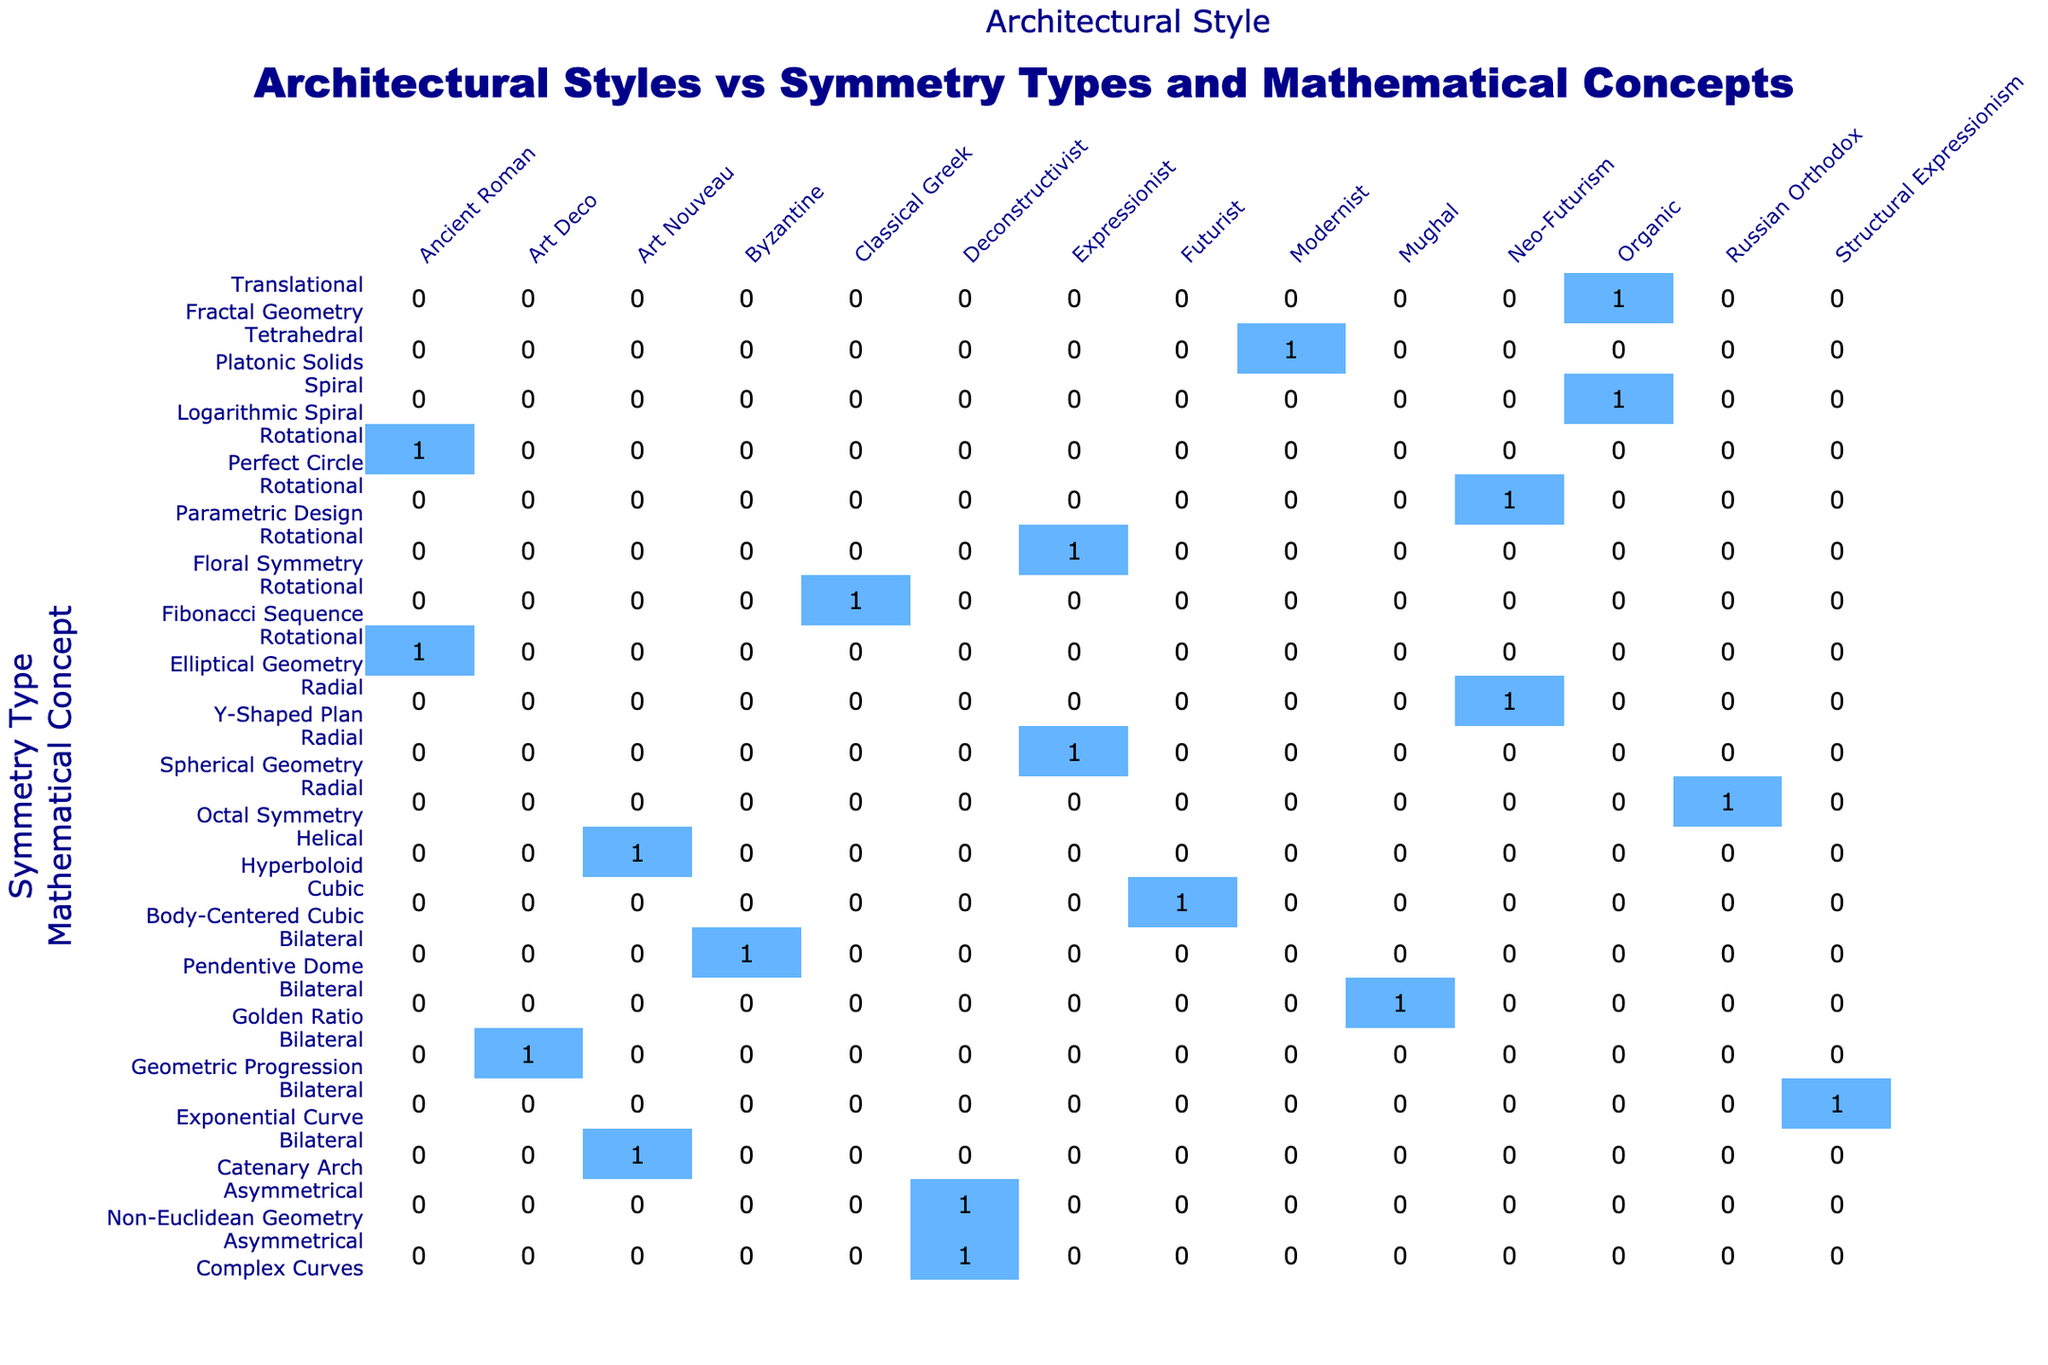What symmetry type is associated with the Guggenheim Museum? The Guggenheim Museum is listed in the table under the "Symmetry Type" column, where its entry shows "Spiral." Therefore, that's the associated symmetry type.
Answer: Spiral How many buildings exhibit Radial symmetry? To find the number of buildings with Radial symmetry, look at the "Symmetry Type" row for Radial in the table. Both the Sydney Opera House, Burj Khalifa, St. Basil's Cathedral, and Lotus Temple are classified under this symmetry type, giving a total of four buildings.
Answer: 4 Is the Sagrada Familia designed in the Art Deco style? The table indicates that the Sagrada Familia is categorized under "Architectural Style" as Art Nouveau, not Art Deco. Hence, the statement is false.
Answer: No Which mathematical concept is associated with the Colosseum? The Colosseum entry in the table indicates that it is related to "Elliptical Geometry" in the "Mathematical Concept" column. This information is used to answer the question directly by referring to that entry.
Answer: Elliptical Geometry How many buildings are designed by architects in the Deconstructivist style? In the table, the "Architectural Style" column shows that there are two entries for "Deconstructivist," one for the Dancing House and one for the Walt Disney Concert Hall. Adding these gives a total of two buildings designed in this style.
Answer: 2 What is the mathematical concept that corresponds to the Pantheon? The Pantheon entry lists "Perfect Circle" in the "Mathematical Concept" column, indicating that this is the associated concept for the Pantheon.
Answer: Perfect Circle Are there more buildings with Bilateral symmetry than with Asymmetrical symmetry? Upon reviewing the table, there are five entries for Bilateral symmetry (including Taj Mahal, Casa Batlló, etc.) and two entries for Asymmetrical symmetry (Dancing House and Walt Disney Concert Hall). Therefore, the statement is true.
Answer: Yes What is the total number of buildings designed in Ancient Roman style compared to the Modernist style? The entries indicate that there are two buildings in the Ancient Roman style (Colosseum and Pantheon) and one building in the Modernist style (Louvre Pyramid). Therefore, there are more Ancient Roman buildings than Modernist buildings: 2 vs 1.
Answer: 2 vs 1 Which symmetry type is most commonly associated with the Mathematical Concept "Golden Ratio"? The table shows that the Taj Mahal is the only building associated with the "Golden Ratio," and it is categorized under "Bilateral" symmetry. Therefore, the common symmetry type for this concept is Bilateral.
Answer: Bilateral 